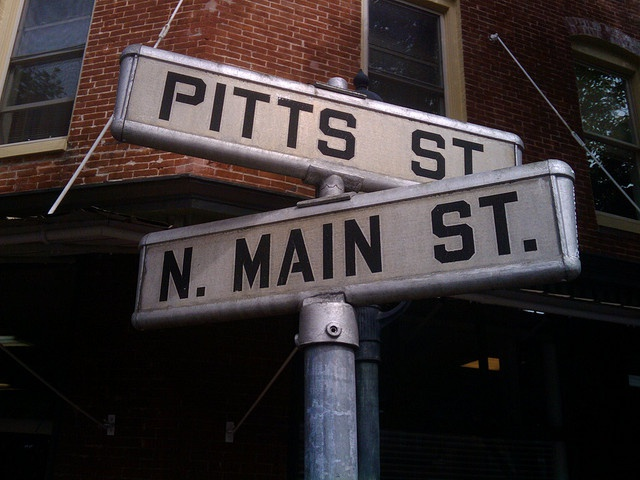Describe the objects in this image and their specific colors. I can see various objects in this image with different colors. 